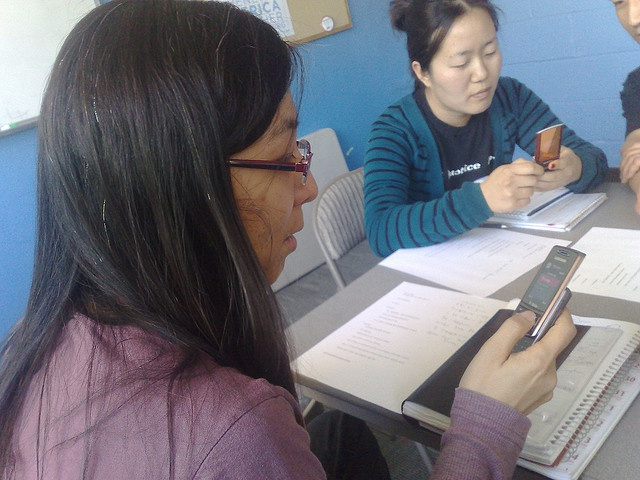Describe the objects in this image and their specific colors. I can see people in white, black, gray, and darkgray tones, people in white, blue, navy, teal, and darkgray tones, book in white, lightgray, darkgray, and gray tones, book in white, darkgray, lightgray, and gray tones, and chair in white, darkgray, and gray tones in this image. 